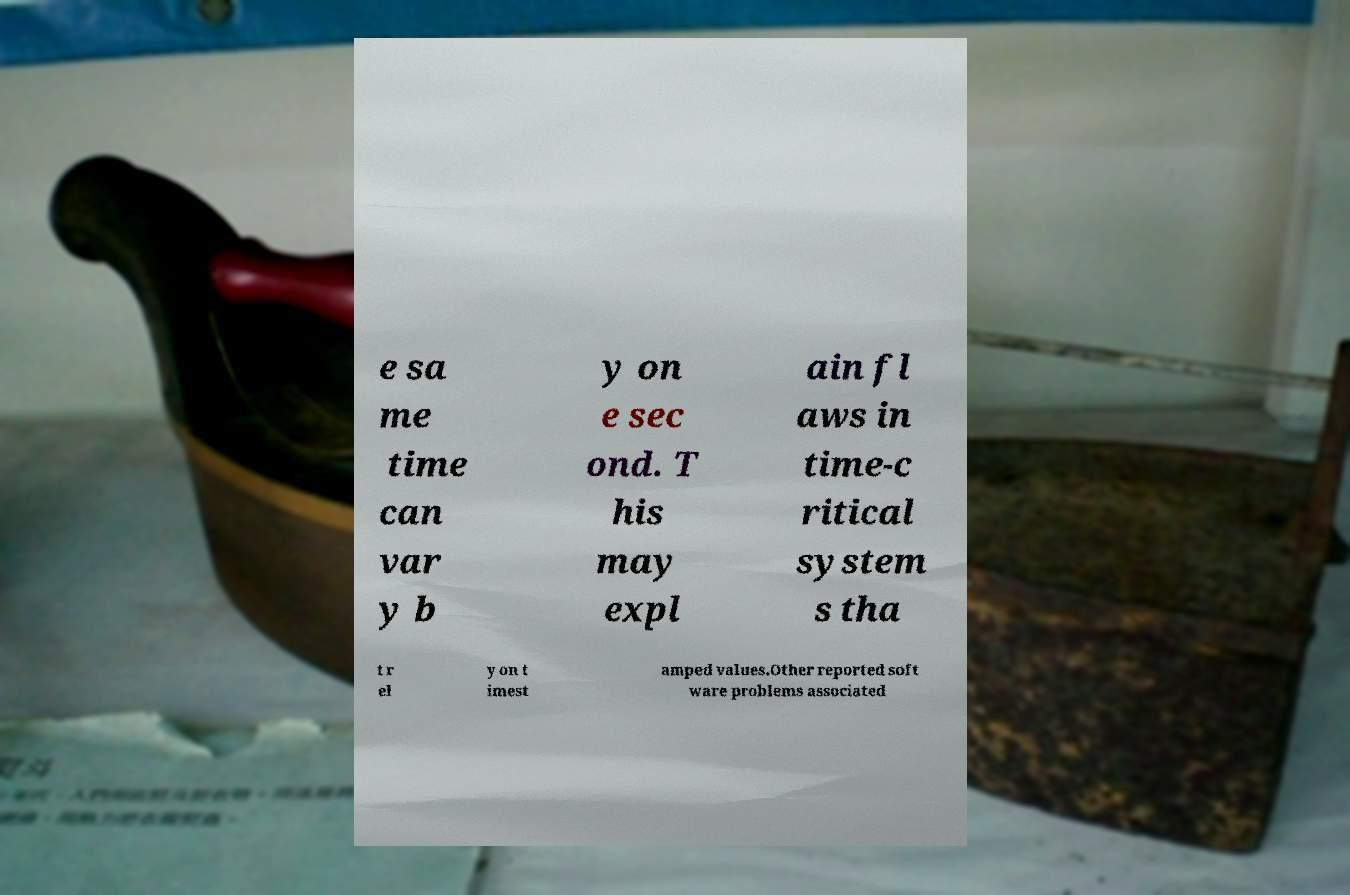I need the written content from this picture converted into text. Can you do that? e sa me time can var y b y on e sec ond. T his may expl ain fl aws in time-c ritical system s tha t r el y on t imest amped values.Other reported soft ware problems associated 